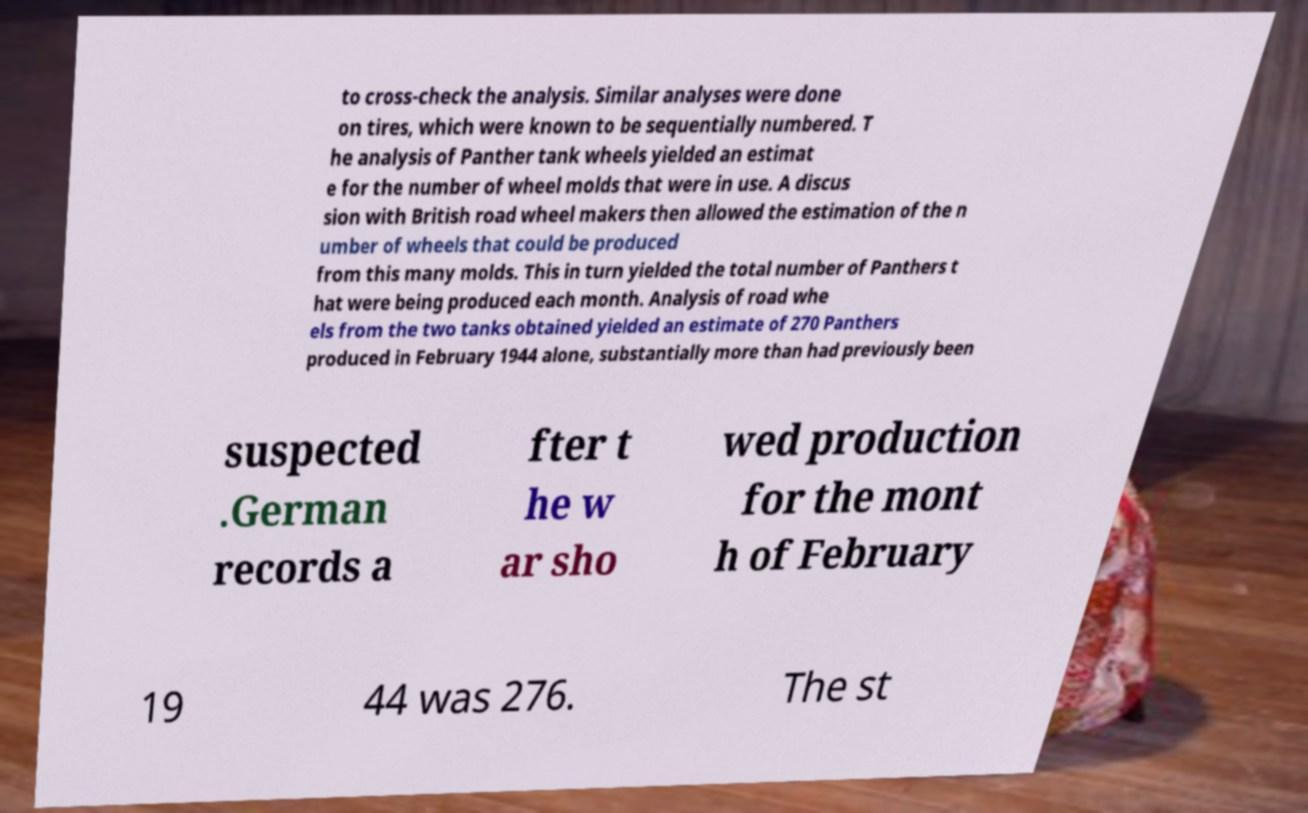What messages or text are displayed in this image? I need them in a readable, typed format. to cross-check the analysis. Similar analyses were done on tires, which were known to be sequentially numbered. T he analysis of Panther tank wheels yielded an estimat e for the number of wheel molds that were in use. A discus sion with British road wheel makers then allowed the estimation of the n umber of wheels that could be produced from this many molds. This in turn yielded the total number of Panthers t hat were being produced each month. Analysis of road whe els from the two tanks obtained yielded an estimate of 270 Panthers produced in February 1944 alone, substantially more than had previously been suspected .German records a fter t he w ar sho wed production for the mont h of February 19 44 was 276. The st 